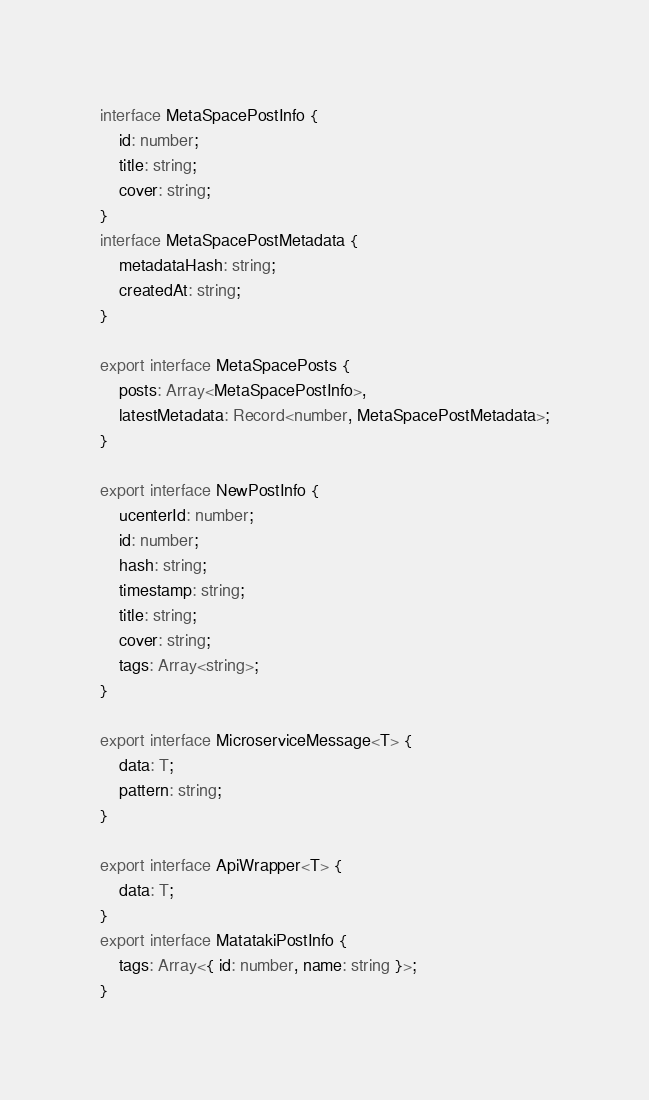Convert code to text. <code><loc_0><loc_0><loc_500><loc_500><_TypeScript_>interface MetaSpacePostInfo {
    id: number;
    title: string;
    cover: string;
}
interface MetaSpacePostMetadata {
    metadataHash: string;
    createdAt: string;
}

export interface MetaSpacePosts {
    posts: Array<MetaSpacePostInfo>,
    latestMetadata: Record<number, MetaSpacePostMetadata>;
}

export interface NewPostInfo {
    ucenterId: number;
    id: number;
    hash: string;
    timestamp: string;
    title: string;
    cover: string;
    tags: Array<string>;
}

export interface MicroserviceMessage<T> {
    data: T;
    pattern: string;
}

export interface ApiWrapper<T> {
    data: T;
}
export interface MatatakiPostInfo {
    tags: Array<{ id: number, name: string }>;
}
</code> 